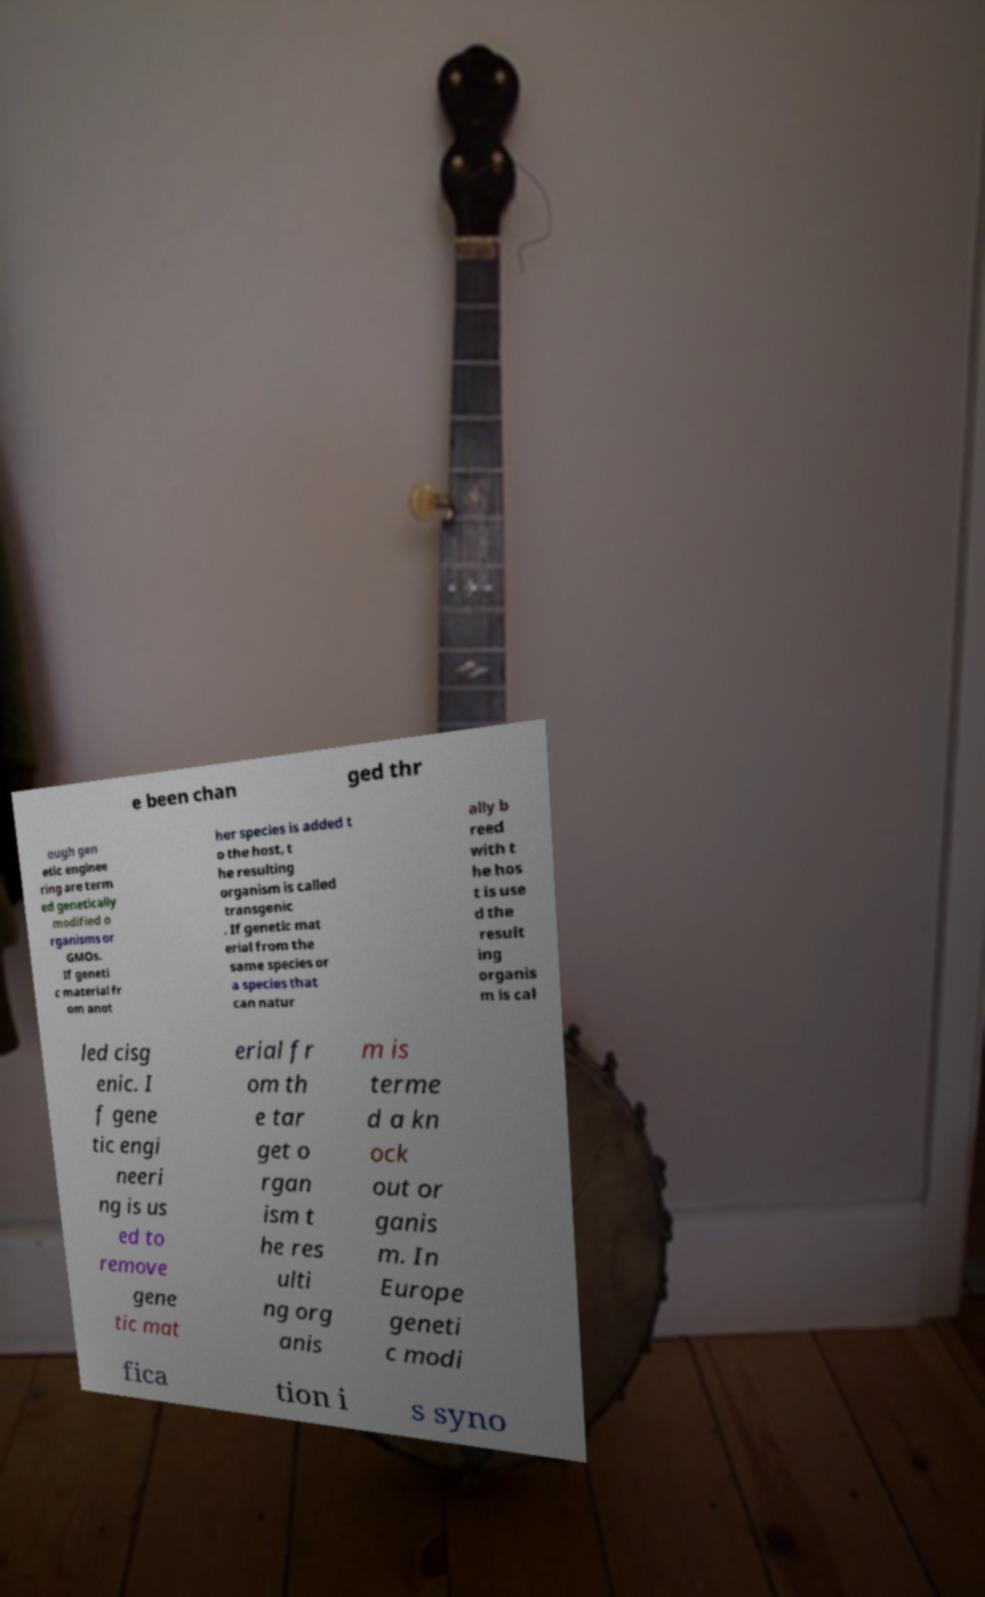Please identify and transcribe the text found in this image. e been chan ged thr ough gen etic enginee ring are term ed genetically modified o rganisms or GMOs. If geneti c material fr om anot her species is added t o the host, t he resulting organism is called transgenic . If genetic mat erial from the same species or a species that can natur ally b reed with t he hos t is use d the result ing organis m is cal led cisg enic. I f gene tic engi neeri ng is us ed to remove gene tic mat erial fr om th e tar get o rgan ism t he res ulti ng org anis m is terme d a kn ock out or ganis m. In Europe geneti c modi fica tion i s syno 